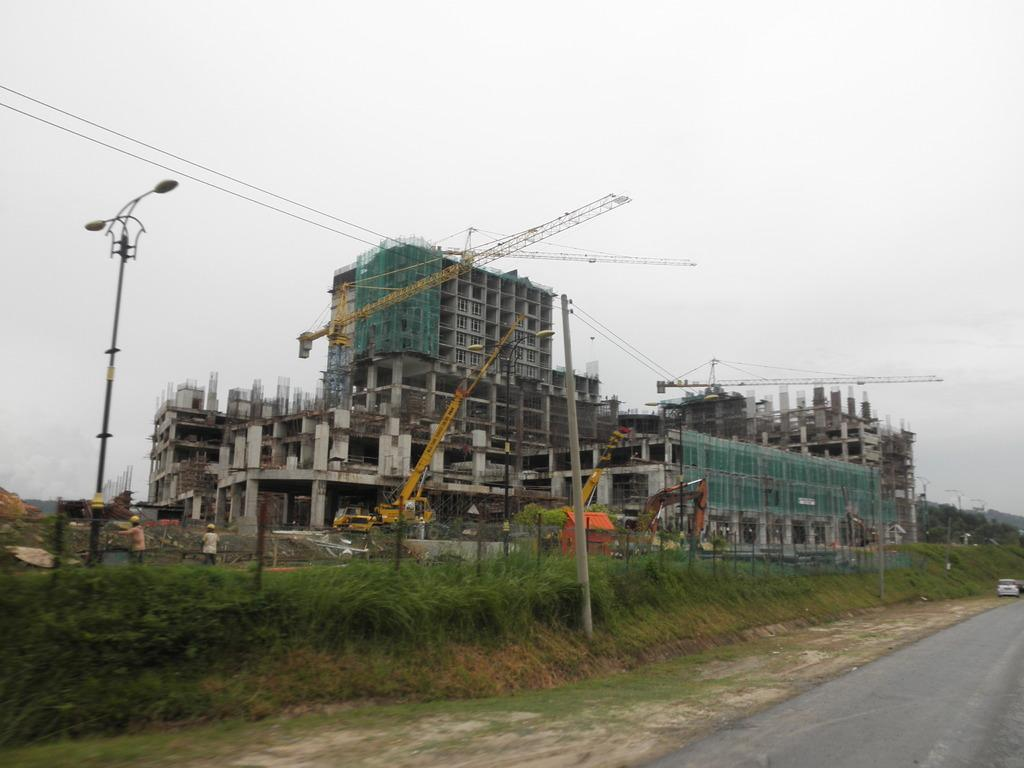What type of vegetation can be seen in the image? There is grass in the image. What type of infrastructure is present in the image? There is a road and lights on a pole in the image. What can be seen in the background of the image? In the background, there are people visible, cranes, under-construction buildings, and the sky. What type of account is being discussed by the rabbit in the image? There is no rabbit present in the image, and therefore no account is being discussed. What is the reason for the war in the image? There is no war present in the image, and therefore no reason can be determined. 